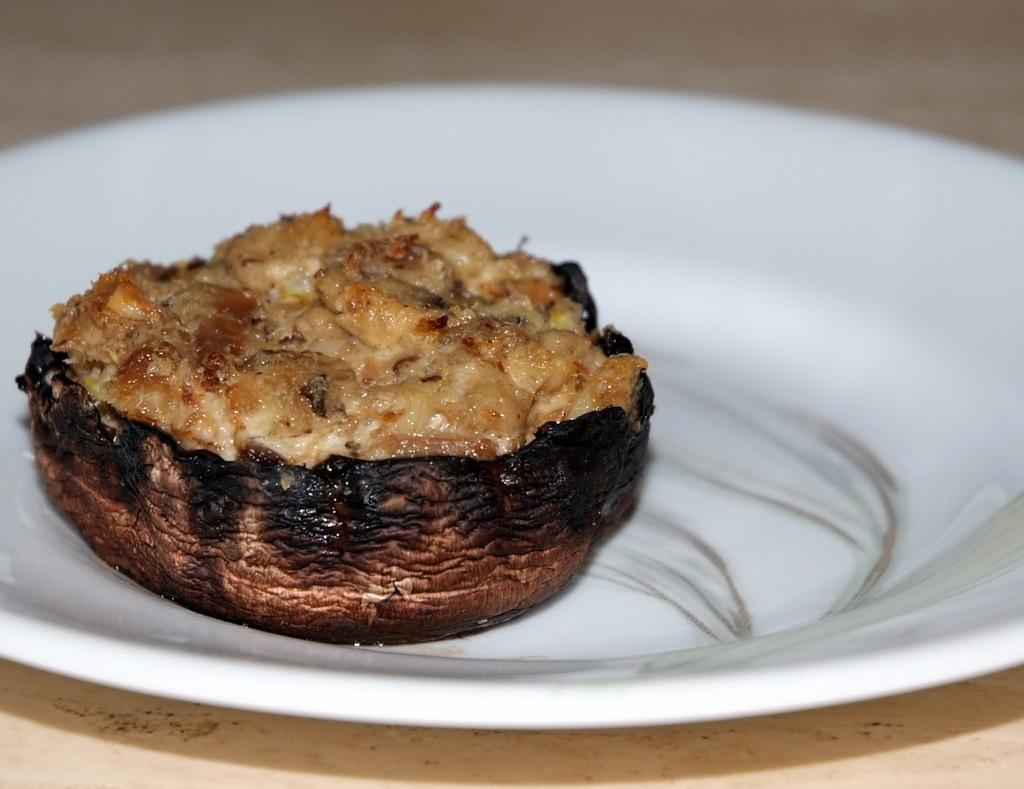How would you summarize this image in a sentence or two? In this image in the center there is a plate and in the plate there is some food, at the bottom it looks like a table. 